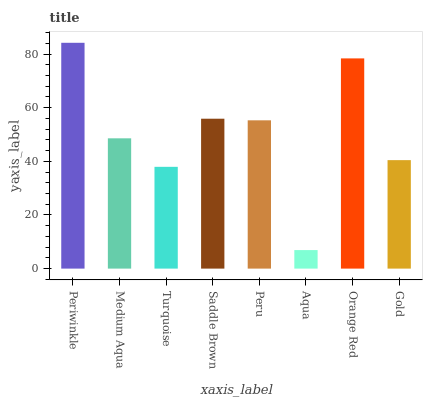Is Aqua the minimum?
Answer yes or no. Yes. Is Periwinkle the maximum?
Answer yes or no. Yes. Is Medium Aqua the minimum?
Answer yes or no. No. Is Medium Aqua the maximum?
Answer yes or no. No. Is Periwinkle greater than Medium Aqua?
Answer yes or no. Yes. Is Medium Aqua less than Periwinkle?
Answer yes or no. Yes. Is Medium Aqua greater than Periwinkle?
Answer yes or no. No. Is Periwinkle less than Medium Aqua?
Answer yes or no. No. Is Peru the high median?
Answer yes or no. Yes. Is Medium Aqua the low median?
Answer yes or no. Yes. Is Turquoise the high median?
Answer yes or no. No. Is Periwinkle the low median?
Answer yes or no. No. 